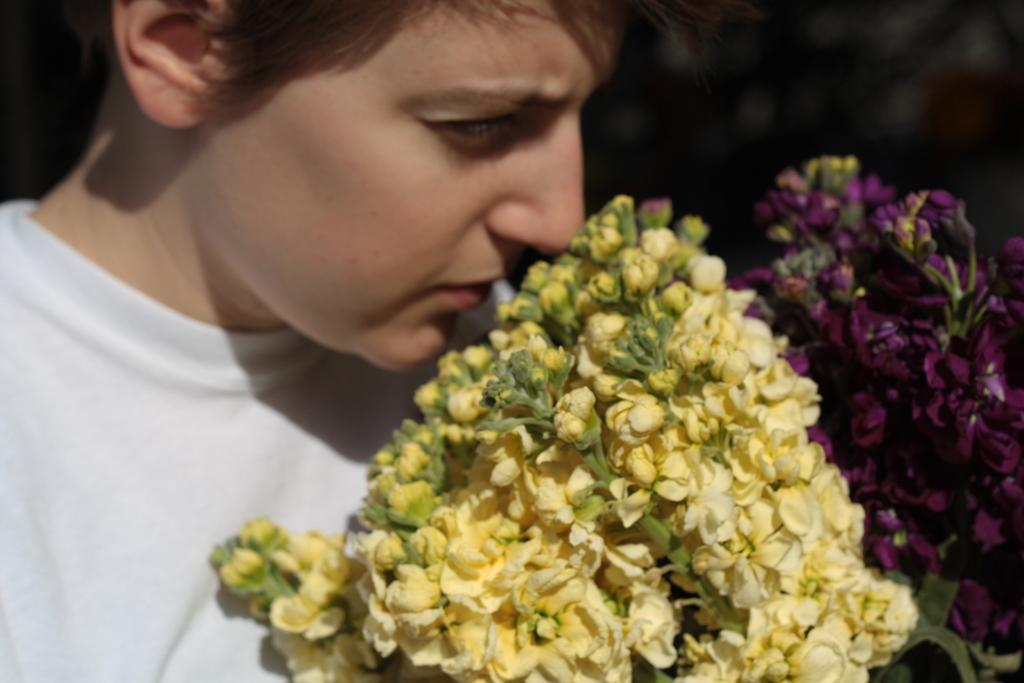Could you give a brief overview of what you see in this image? In this image there is a person standing in front of the flowers. 